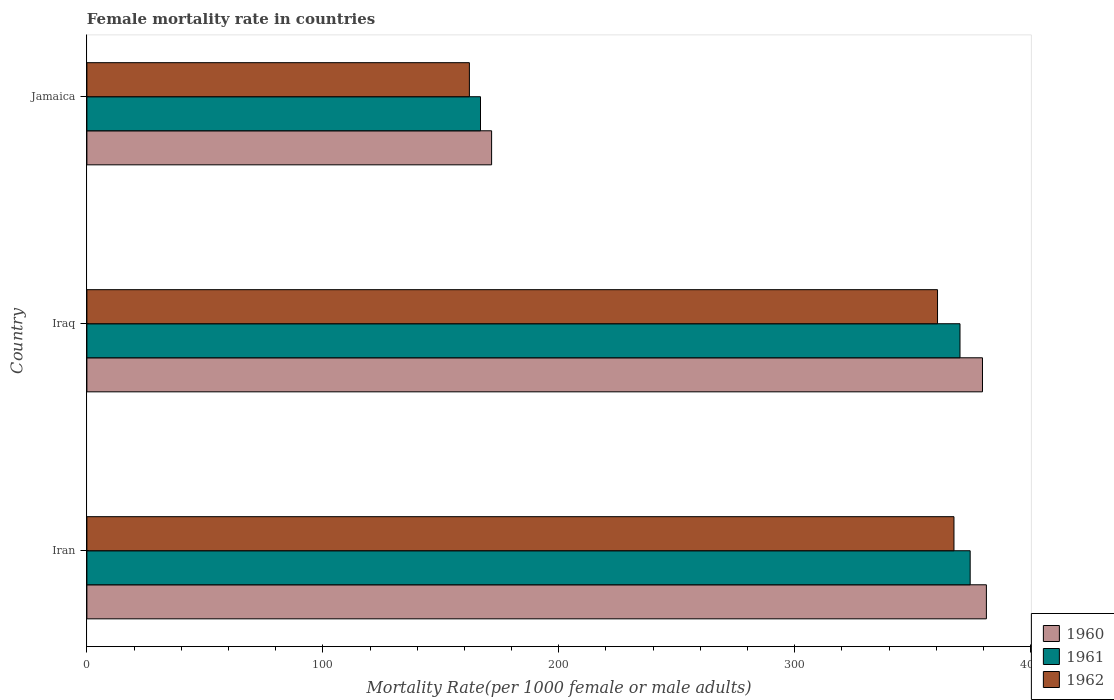How many bars are there on the 2nd tick from the top?
Your answer should be compact. 3. What is the label of the 2nd group of bars from the top?
Make the answer very short. Iraq. In how many cases, is the number of bars for a given country not equal to the number of legend labels?
Keep it short and to the point. 0. What is the female mortality rate in 1962 in Iraq?
Provide a short and direct response. 360.53. Across all countries, what is the maximum female mortality rate in 1962?
Provide a succinct answer. 367.5. Across all countries, what is the minimum female mortality rate in 1961?
Offer a very short reply. 166.82. In which country was the female mortality rate in 1960 maximum?
Keep it short and to the point. Iran. In which country was the female mortality rate in 1960 minimum?
Offer a very short reply. Jamaica. What is the total female mortality rate in 1962 in the graph?
Offer a terse response. 890.14. What is the difference between the female mortality rate in 1961 in Iran and that in Iraq?
Provide a succinct answer. 4.31. What is the difference between the female mortality rate in 1962 in Jamaica and the female mortality rate in 1961 in Iran?
Your answer should be compact. -212.26. What is the average female mortality rate in 1962 per country?
Your response must be concise. 296.71. What is the difference between the female mortality rate in 1960 and female mortality rate in 1962 in Iraq?
Your answer should be compact. 19.05. What is the ratio of the female mortality rate in 1962 in Iran to that in Iraq?
Offer a terse response. 1.02. What is the difference between the highest and the second highest female mortality rate in 1960?
Your answer should be compact. 1.66. What is the difference between the highest and the lowest female mortality rate in 1961?
Your response must be concise. 207.55. What does the 2nd bar from the bottom in Iran represents?
Keep it short and to the point. 1961. How many bars are there?
Keep it short and to the point. 9. Are all the bars in the graph horizontal?
Ensure brevity in your answer.  Yes. Does the graph contain grids?
Provide a short and direct response. No. How many legend labels are there?
Your response must be concise. 3. How are the legend labels stacked?
Provide a succinct answer. Vertical. What is the title of the graph?
Provide a short and direct response. Female mortality rate in countries. What is the label or title of the X-axis?
Your answer should be compact. Mortality Rate(per 1000 female or male adults). What is the label or title of the Y-axis?
Provide a succinct answer. Country. What is the Mortality Rate(per 1000 female or male adults) of 1960 in Iran?
Offer a very short reply. 381.24. What is the Mortality Rate(per 1000 female or male adults) in 1961 in Iran?
Offer a very short reply. 374.37. What is the Mortality Rate(per 1000 female or male adults) of 1962 in Iran?
Your response must be concise. 367.5. What is the Mortality Rate(per 1000 female or male adults) of 1960 in Iraq?
Offer a terse response. 379.58. What is the Mortality Rate(per 1000 female or male adults) of 1961 in Iraq?
Your answer should be compact. 370.06. What is the Mortality Rate(per 1000 female or male adults) of 1962 in Iraq?
Provide a succinct answer. 360.53. What is the Mortality Rate(per 1000 female or male adults) of 1960 in Jamaica?
Provide a succinct answer. 171.53. What is the Mortality Rate(per 1000 female or male adults) in 1961 in Jamaica?
Ensure brevity in your answer.  166.82. What is the Mortality Rate(per 1000 female or male adults) in 1962 in Jamaica?
Give a very brief answer. 162.11. Across all countries, what is the maximum Mortality Rate(per 1000 female or male adults) in 1960?
Provide a succinct answer. 381.24. Across all countries, what is the maximum Mortality Rate(per 1000 female or male adults) in 1961?
Your answer should be compact. 374.37. Across all countries, what is the maximum Mortality Rate(per 1000 female or male adults) of 1962?
Give a very brief answer. 367.5. Across all countries, what is the minimum Mortality Rate(per 1000 female or male adults) of 1960?
Your answer should be compact. 171.53. Across all countries, what is the minimum Mortality Rate(per 1000 female or male adults) of 1961?
Make the answer very short. 166.82. Across all countries, what is the minimum Mortality Rate(per 1000 female or male adults) in 1962?
Your answer should be compact. 162.11. What is the total Mortality Rate(per 1000 female or male adults) of 1960 in the graph?
Keep it short and to the point. 932.36. What is the total Mortality Rate(per 1000 female or male adults) in 1961 in the graph?
Keep it short and to the point. 911.25. What is the total Mortality Rate(per 1000 female or male adults) in 1962 in the graph?
Keep it short and to the point. 890.14. What is the difference between the Mortality Rate(per 1000 female or male adults) in 1960 in Iran and that in Iraq?
Ensure brevity in your answer.  1.66. What is the difference between the Mortality Rate(per 1000 female or male adults) of 1961 in Iran and that in Iraq?
Provide a succinct answer. 4.31. What is the difference between the Mortality Rate(per 1000 female or male adults) of 1962 in Iran and that in Iraq?
Your answer should be very brief. 6.97. What is the difference between the Mortality Rate(per 1000 female or male adults) in 1960 in Iran and that in Jamaica?
Your answer should be compact. 209.71. What is the difference between the Mortality Rate(per 1000 female or male adults) in 1961 in Iran and that in Jamaica?
Your answer should be very brief. 207.55. What is the difference between the Mortality Rate(per 1000 female or male adults) in 1962 in Iran and that in Jamaica?
Provide a succinct answer. 205.38. What is the difference between the Mortality Rate(per 1000 female or male adults) in 1960 in Iraq and that in Jamaica?
Provide a short and direct response. 208.05. What is the difference between the Mortality Rate(per 1000 female or male adults) in 1961 in Iraq and that in Jamaica?
Your answer should be compact. 203.23. What is the difference between the Mortality Rate(per 1000 female or male adults) in 1962 in Iraq and that in Jamaica?
Offer a terse response. 198.42. What is the difference between the Mortality Rate(per 1000 female or male adults) of 1960 in Iran and the Mortality Rate(per 1000 female or male adults) of 1961 in Iraq?
Offer a very short reply. 11.19. What is the difference between the Mortality Rate(per 1000 female or male adults) in 1960 in Iran and the Mortality Rate(per 1000 female or male adults) in 1962 in Iraq?
Provide a succinct answer. 20.71. What is the difference between the Mortality Rate(per 1000 female or male adults) in 1961 in Iran and the Mortality Rate(per 1000 female or male adults) in 1962 in Iraq?
Your answer should be very brief. 13.84. What is the difference between the Mortality Rate(per 1000 female or male adults) of 1960 in Iran and the Mortality Rate(per 1000 female or male adults) of 1961 in Jamaica?
Offer a terse response. 214.42. What is the difference between the Mortality Rate(per 1000 female or male adults) in 1960 in Iran and the Mortality Rate(per 1000 female or male adults) in 1962 in Jamaica?
Keep it short and to the point. 219.13. What is the difference between the Mortality Rate(per 1000 female or male adults) in 1961 in Iran and the Mortality Rate(per 1000 female or male adults) in 1962 in Jamaica?
Your answer should be very brief. 212.25. What is the difference between the Mortality Rate(per 1000 female or male adults) of 1960 in Iraq and the Mortality Rate(per 1000 female or male adults) of 1961 in Jamaica?
Offer a very short reply. 212.76. What is the difference between the Mortality Rate(per 1000 female or male adults) of 1960 in Iraq and the Mortality Rate(per 1000 female or male adults) of 1962 in Jamaica?
Provide a short and direct response. 217.47. What is the difference between the Mortality Rate(per 1000 female or male adults) in 1961 in Iraq and the Mortality Rate(per 1000 female or male adults) in 1962 in Jamaica?
Ensure brevity in your answer.  207.94. What is the average Mortality Rate(per 1000 female or male adults) in 1960 per country?
Offer a terse response. 310.79. What is the average Mortality Rate(per 1000 female or male adults) of 1961 per country?
Ensure brevity in your answer.  303.75. What is the average Mortality Rate(per 1000 female or male adults) of 1962 per country?
Ensure brevity in your answer.  296.71. What is the difference between the Mortality Rate(per 1000 female or male adults) of 1960 and Mortality Rate(per 1000 female or male adults) of 1961 in Iran?
Make the answer very short. 6.87. What is the difference between the Mortality Rate(per 1000 female or male adults) of 1960 and Mortality Rate(per 1000 female or male adults) of 1962 in Iran?
Your answer should be very brief. 13.74. What is the difference between the Mortality Rate(per 1000 female or male adults) of 1961 and Mortality Rate(per 1000 female or male adults) of 1962 in Iran?
Your answer should be compact. 6.87. What is the difference between the Mortality Rate(per 1000 female or male adults) of 1960 and Mortality Rate(per 1000 female or male adults) of 1961 in Iraq?
Your answer should be very brief. 9.53. What is the difference between the Mortality Rate(per 1000 female or male adults) in 1960 and Mortality Rate(per 1000 female or male adults) in 1962 in Iraq?
Your answer should be very brief. 19.05. What is the difference between the Mortality Rate(per 1000 female or male adults) of 1961 and Mortality Rate(per 1000 female or male adults) of 1962 in Iraq?
Offer a terse response. 9.53. What is the difference between the Mortality Rate(per 1000 female or male adults) of 1960 and Mortality Rate(per 1000 female or male adults) of 1961 in Jamaica?
Keep it short and to the point. 4.71. What is the difference between the Mortality Rate(per 1000 female or male adults) in 1960 and Mortality Rate(per 1000 female or male adults) in 1962 in Jamaica?
Give a very brief answer. 9.42. What is the difference between the Mortality Rate(per 1000 female or male adults) of 1961 and Mortality Rate(per 1000 female or male adults) of 1962 in Jamaica?
Give a very brief answer. 4.71. What is the ratio of the Mortality Rate(per 1000 female or male adults) of 1961 in Iran to that in Iraq?
Provide a succinct answer. 1.01. What is the ratio of the Mortality Rate(per 1000 female or male adults) in 1962 in Iran to that in Iraq?
Your answer should be very brief. 1.02. What is the ratio of the Mortality Rate(per 1000 female or male adults) of 1960 in Iran to that in Jamaica?
Offer a very short reply. 2.22. What is the ratio of the Mortality Rate(per 1000 female or male adults) in 1961 in Iran to that in Jamaica?
Your response must be concise. 2.24. What is the ratio of the Mortality Rate(per 1000 female or male adults) of 1962 in Iran to that in Jamaica?
Ensure brevity in your answer.  2.27. What is the ratio of the Mortality Rate(per 1000 female or male adults) of 1960 in Iraq to that in Jamaica?
Your response must be concise. 2.21. What is the ratio of the Mortality Rate(per 1000 female or male adults) of 1961 in Iraq to that in Jamaica?
Your response must be concise. 2.22. What is the ratio of the Mortality Rate(per 1000 female or male adults) of 1962 in Iraq to that in Jamaica?
Offer a very short reply. 2.22. What is the difference between the highest and the second highest Mortality Rate(per 1000 female or male adults) of 1960?
Give a very brief answer. 1.66. What is the difference between the highest and the second highest Mortality Rate(per 1000 female or male adults) in 1961?
Your answer should be very brief. 4.31. What is the difference between the highest and the second highest Mortality Rate(per 1000 female or male adults) of 1962?
Your answer should be very brief. 6.97. What is the difference between the highest and the lowest Mortality Rate(per 1000 female or male adults) of 1960?
Offer a terse response. 209.71. What is the difference between the highest and the lowest Mortality Rate(per 1000 female or male adults) of 1961?
Your answer should be compact. 207.55. What is the difference between the highest and the lowest Mortality Rate(per 1000 female or male adults) in 1962?
Offer a very short reply. 205.38. 